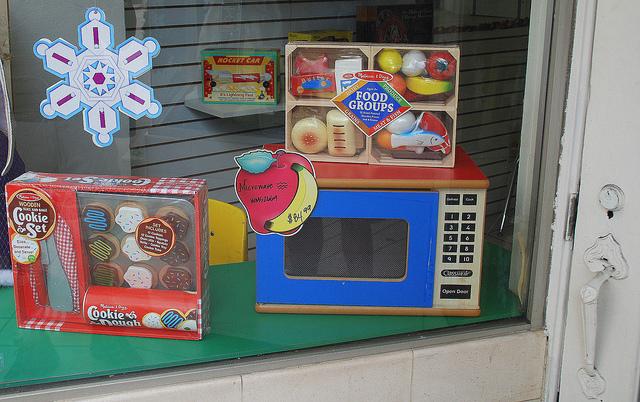What kind of rack  is above the stove?
Answer briefly. Food. What color is the door?
Write a very short answer. White. What kind of model is this?
Keep it brief. Toy. How many toys are behind the window?
Give a very brief answer. 4. Is there a snowflake?
Quick response, please. Yes. 